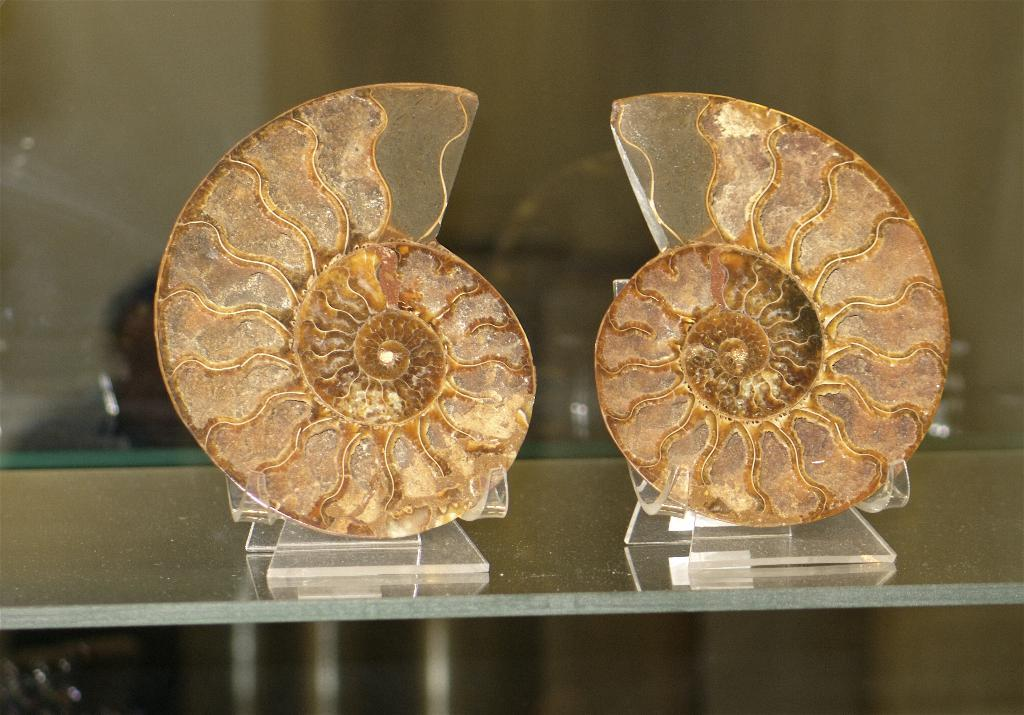What objects are present in the image? There are two shields in the image. How are the shields arranged? The shields are placed on a rack. Can you describe the background of the image? There is a person visible in the background of the image, but it is blurry. What type of design can be seen on the fairies in the image? There are no fairies present in the image; it only features two shields placed on a rack and a blurry person in the background. 